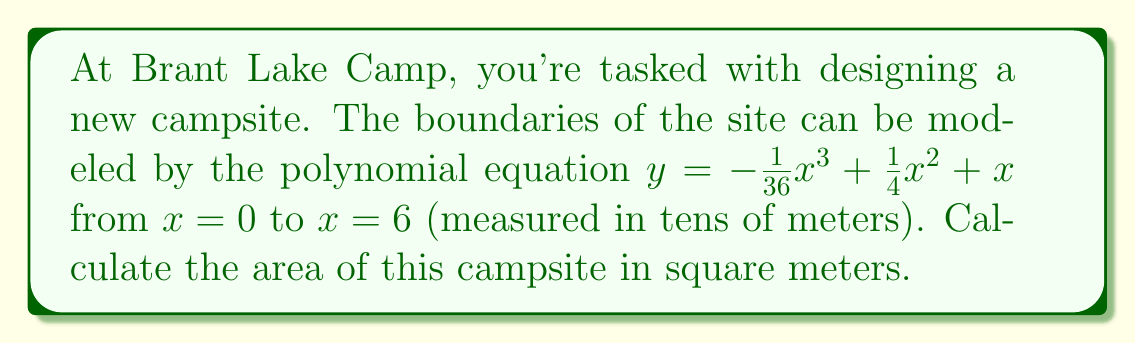Can you answer this question? To find the area of the campsite, we need to calculate the definite integral of the given polynomial function from $x = 0$ to $x = 6$.

1) The area is given by the integral:
   $$A = \int_0^6 \left(-\frac{1}{36}x^3 + \frac{1}{4}x^2 + x\right) dx$$

2) Integrate the polynomial term by term:
   $$A = \left[-\frac{1}{144}x^4 + \frac{1}{12}x^3 + \frac{1}{2}x^2\right]_0^6$$

3) Evaluate the integral at the upper and lower bounds:
   $$A = \left(-\frac{1}{144}(6^4) + \frac{1}{12}(6^3) + \frac{1}{2}(6^2)\right) - \left(-\frac{1}{144}(0^4) + \frac{1}{12}(0^3) + \frac{1}{2}(0^2)\right)$$

4) Simplify:
   $$A = \left(-\frac{1296}{144} + \frac{216}{12} + \frac{36}{2}\right) - 0$$
   $$A = -9 + 18 + 18 = 27$$

5) Since x was measured in tens of meters, we need to multiply our result by 100 to get the area in square meters:
   $$A = 27 * 100 = 2700 \text{ m}^2$$

Therefore, the area of the campsite is 2700 square meters.
Answer: 2700 m² 